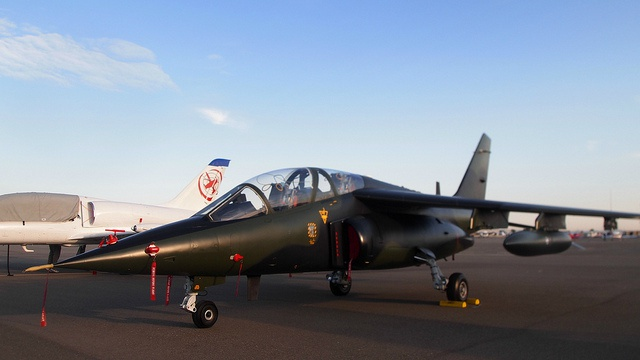Describe the objects in this image and their specific colors. I can see a airplane in lightblue, black, gray, and lightgray tones in this image. 